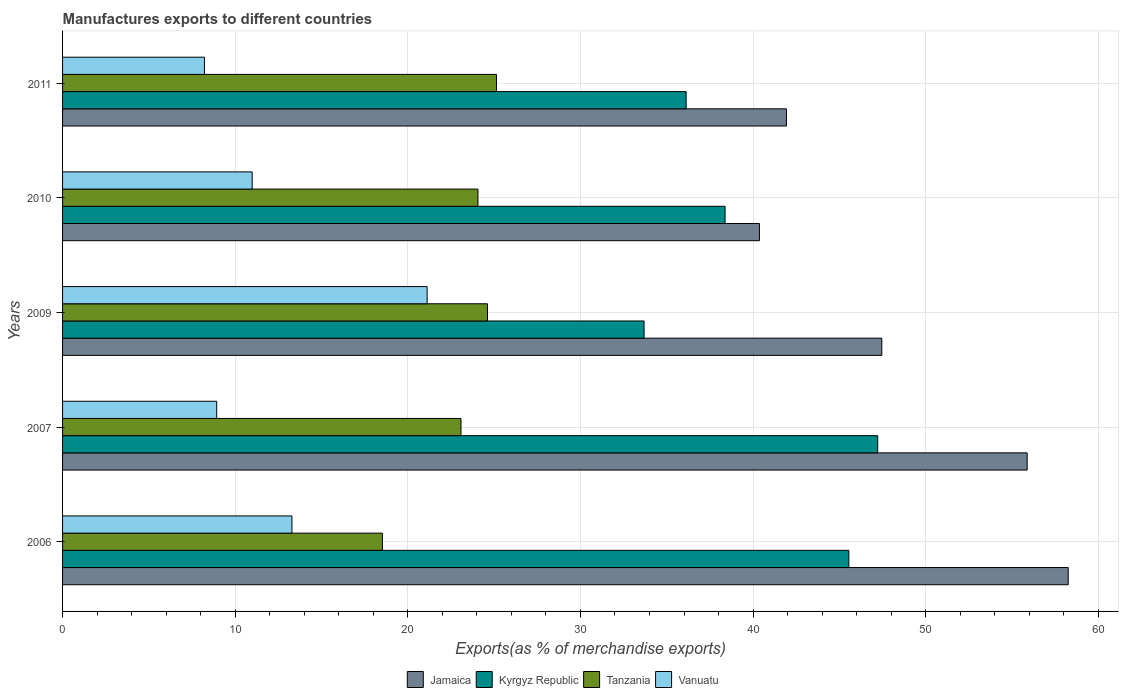How many different coloured bars are there?
Make the answer very short. 4. How many groups of bars are there?
Offer a very short reply. 5. What is the percentage of exports to different countries in Kyrgyz Republic in 2007?
Offer a very short reply. 47.22. Across all years, what is the maximum percentage of exports to different countries in Jamaica?
Make the answer very short. 58.26. Across all years, what is the minimum percentage of exports to different countries in Vanuatu?
Your answer should be compact. 8.22. What is the total percentage of exports to different countries in Kyrgyz Republic in the graph?
Your response must be concise. 200.95. What is the difference between the percentage of exports to different countries in Kyrgyz Republic in 2007 and that in 2009?
Keep it short and to the point. 13.53. What is the difference between the percentage of exports to different countries in Kyrgyz Republic in 2010 and the percentage of exports to different countries in Tanzania in 2007?
Keep it short and to the point. 15.3. What is the average percentage of exports to different countries in Tanzania per year?
Your response must be concise. 23.08. In the year 2007, what is the difference between the percentage of exports to different countries in Kyrgyz Republic and percentage of exports to different countries in Tanzania?
Make the answer very short. 24.14. What is the ratio of the percentage of exports to different countries in Kyrgyz Republic in 2010 to that in 2011?
Offer a very short reply. 1.06. Is the percentage of exports to different countries in Tanzania in 2006 less than that in 2010?
Ensure brevity in your answer.  Yes. Is the difference between the percentage of exports to different countries in Kyrgyz Republic in 2010 and 2011 greater than the difference between the percentage of exports to different countries in Tanzania in 2010 and 2011?
Provide a succinct answer. Yes. What is the difference between the highest and the second highest percentage of exports to different countries in Jamaica?
Offer a very short reply. 2.38. What is the difference between the highest and the lowest percentage of exports to different countries in Tanzania?
Make the answer very short. 6.61. Is it the case that in every year, the sum of the percentage of exports to different countries in Vanuatu and percentage of exports to different countries in Jamaica is greater than the sum of percentage of exports to different countries in Tanzania and percentage of exports to different countries in Kyrgyz Republic?
Ensure brevity in your answer.  Yes. What does the 1st bar from the top in 2006 represents?
Provide a succinct answer. Vanuatu. What does the 2nd bar from the bottom in 2010 represents?
Offer a terse response. Kyrgyz Republic. Is it the case that in every year, the sum of the percentage of exports to different countries in Tanzania and percentage of exports to different countries in Jamaica is greater than the percentage of exports to different countries in Kyrgyz Republic?
Give a very brief answer. Yes. How many years are there in the graph?
Offer a very short reply. 5. Does the graph contain any zero values?
Provide a succinct answer. No. What is the title of the graph?
Offer a very short reply. Manufactures exports to different countries. What is the label or title of the X-axis?
Offer a very short reply. Exports(as % of merchandise exports). What is the Exports(as % of merchandise exports) of Jamaica in 2006?
Offer a very short reply. 58.26. What is the Exports(as % of merchandise exports) of Kyrgyz Republic in 2006?
Offer a very short reply. 45.55. What is the Exports(as % of merchandise exports) in Tanzania in 2006?
Offer a terse response. 18.53. What is the Exports(as % of merchandise exports) of Vanuatu in 2006?
Keep it short and to the point. 13.29. What is the Exports(as % of merchandise exports) in Jamaica in 2007?
Provide a short and direct response. 55.88. What is the Exports(as % of merchandise exports) of Kyrgyz Republic in 2007?
Your response must be concise. 47.22. What is the Exports(as % of merchandise exports) of Tanzania in 2007?
Give a very brief answer. 23.08. What is the Exports(as % of merchandise exports) in Vanuatu in 2007?
Your response must be concise. 8.93. What is the Exports(as % of merchandise exports) in Jamaica in 2009?
Keep it short and to the point. 47.46. What is the Exports(as % of merchandise exports) of Kyrgyz Republic in 2009?
Offer a terse response. 33.69. What is the Exports(as % of merchandise exports) in Tanzania in 2009?
Offer a terse response. 24.61. What is the Exports(as % of merchandise exports) of Vanuatu in 2009?
Keep it short and to the point. 21.12. What is the Exports(as % of merchandise exports) in Jamaica in 2010?
Make the answer very short. 40.37. What is the Exports(as % of merchandise exports) in Kyrgyz Republic in 2010?
Provide a succinct answer. 38.38. What is the Exports(as % of merchandise exports) of Tanzania in 2010?
Provide a short and direct response. 24.06. What is the Exports(as % of merchandise exports) in Vanuatu in 2010?
Your response must be concise. 10.98. What is the Exports(as % of merchandise exports) of Jamaica in 2011?
Provide a short and direct response. 41.93. What is the Exports(as % of merchandise exports) in Kyrgyz Republic in 2011?
Give a very brief answer. 36.12. What is the Exports(as % of merchandise exports) in Tanzania in 2011?
Provide a short and direct response. 25.14. What is the Exports(as % of merchandise exports) of Vanuatu in 2011?
Your response must be concise. 8.22. Across all years, what is the maximum Exports(as % of merchandise exports) in Jamaica?
Your answer should be very brief. 58.26. Across all years, what is the maximum Exports(as % of merchandise exports) in Kyrgyz Republic?
Your answer should be compact. 47.22. Across all years, what is the maximum Exports(as % of merchandise exports) in Tanzania?
Provide a short and direct response. 25.14. Across all years, what is the maximum Exports(as % of merchandise exports) of Vanuatu?
Your answer should be compact. 21.12. Across all years, what is the minimum Exports(as % of merchandise exports) of Jamaica?
Offer a terse response. 40.37. Across all years, what is the minimum Exports(as % of merchandise exports) in Kyrgyz Republic?
Give a very brief answer. 33.69. Across all years, what is the minimum Exports(as % of merchandise exports) of Tanzania?
Provide a short and direct response. 18.53. Across all years, what is the minimum Exports(as % of merchandise exports) of Vanuatu?
Provide a short and direct response. 8.22. What is the total Exports(as % of merchandise exports) in Jamaica in the graph?
Offer a terse response. 243.89. What is the total Exports(as % of merchandise exports) in Kyrgyz Republic in the graph?
Keep it short and to the point. 200.95. What is the total Exports(as % of merchandise exports) in Tanzania in the graph?
Make the answer very short. 115.42. What is the total Exports(as % of merchandise exports) of Vanuatu in the graph?
Offer a very short reply. 62.54. What is the difference between the Exports(as % of merchandise exports) of Jamaica in 2006 and that in 2007?
Offer a very short reply. 2.38. What is the difference between the Exports(as % of merchandise exports) in Kyrgyz Republic in 2006 and that in 2007?
Your response must be concise. -1.67. What is the difference between the Exports(as % of merchandise exports) of Tanzania in 2006 and that in 2007?
Your answer should be compact. -4.55. What is the difference between the Exports(as % of merchandise exports) of Vanuatu in 2006 and that in 2007?
Make the answer very short. 4.36. What is the difference between the Exports(as % of merchandise exports) in Jamaica in 2006 and that in 2009?
Ensure brevity in your answer.  10.8. What is the difference between the Exports(as % of merchandise exports) of Kyrgyz Republic in 2006 and that in 2009?
Offer a very short reply. 11.86. What is the difference between the Exports(as % of merchandise exports) of Tanzania in 2006 and that in 2009?
Offer a very short reply. -6.09. What is the difference between the Exports(as % of merchandise exports) in Vanuatu in 2006 and that in 2009?
Your answer should be very brief. -7.83. What is the difference between the Exports(as % of merchandise exports) of Jamaica in 2006 and that in 2010?
Your response must be concise. 17.89. What is the difference between the Exports(as % of merchandise exports) of Kyrgyz Republic in 2006 and that in 2010?
Offer a terse response. 7.17. What is the difference between the Exports(as % of merchandise exports) of Tanzania in 2006 and that in 2010?
Offer a terse response. -5.54. What is the difference between the Exports(as % of merchandise exports) of Vanuatu in 2006 and that in 2010?
Give a very brief answer. 2.3. What is the difference between the Exports(as % of merchandise exports) of Jamaica in 2006 and that in 2011?
Give a very brief answer. 16.32. What is the difference between the Exports(as % of merchandise exports) of Kyrgyz Republic in 2006 and that in 2011?
Offer a very short reply. 9.43. What is the difference between the Exports(as % of merchandise exports) of Tanzania in 2006 and that in 2011?
Make the answer very short. -6.61. What is the difference between the Exports(as % of merchandise exports) in Vanuatu in 2006 and that in 2011?
Provide a short and direct response. 5.07. What is the difference between the Exports(as % of merchandise exports) in Jamaica in 2007 and that in 2009?
Offer a terse response. 8.42. What is the difference between the Exports(as % of merchandise exports) in Kyrgyz Republic in 2007 and that in 2009?
Offer a terse response. 13.53. What is the difference between the Exports(as % of merchandise exports) of Tanzania in 2007 and that in 2009?
Offer a very short reply. -1.53. What is the difference between the Exports(as % of merchandise exports) in Vanuatu in 2007 and that in 2009?
Offer a very short reply. -12.19. What is the difference between the Exports(as % of merchandise exports) in Jamaica in 2007 and that in 2010?
Give a very brief answer. 15.51. What is the difference between the Exports(as % of merchandise exports) of Kyrgyz Republic in 2007 and that in 2010?
Make the answer very short. 8.84. What is the difference between the Exports(as % of merchandise exports) in Tanzania in 2007 and that in 2010?
Provide a short and direct response. -0.98. What is the difference between the Exports(as % of merchandise exports) of Vanuatu in 2007 and that in 2010?
Make the answer very short. -2.05. What is the difference between the Exports(as % of merchandise exports) in Jamaica in 2007 and that in 2011?
Your response must be concise. 13.94. What is the difference between the Exports(as % of merchandise exports) in Kyrgyz Republic in 2007 and that in 2011?
Your answer should be very brief. 11.1. What is the difference between the Exports(as % of merchandise exports) in Tanzania in 2007 and that in 2011?
Keep it short and to the point. -2.06. What is the difference between the Exports(as % of merchandise exports) of Vanuatu in 2007 and that in 2011?
Your response must be concise. 0.71. What is the difference between the Exports(as % of merchandise exports) of Jamaica in 2009 and that in 2010?
Offer a terse response. 7.09. What is the difference between the Exports(as % of merchandise exports) in Kyrgyz Republic in 2009 and that in 2010?
Your answer should be very brief. -4.69. What is the difference between the Exports(as % of merchandise exports) of Tanzania in 2009 and that in 2010?
Ensure brevity in your answer.  0.55. What is the difference between the Exports(as % of merchandise exports) of Vanuatu in 2009 and that in 2010?
Your answer should be compact. 10.13. What is the difference between the Exports(as % of merchandise exports) in Jamaica in 2009 and that in 2011?
Give a very brief answer. 5.52. What is the difference between the Exports(as % of merchandise exports) in Kyrgyz Republic in 2009 and that in 2011?
Provide a short and direct response. -2.44. What is the difference between the Exports(as % of merchandise exports) of Tanzania in 2009 and that in 2011?
Ensure brevity in your answer.  -0.52. What is the difference between the Exports(as % of merchandise exports) in Vanuatu in 2009 and that in 2011?
Offer a very short reply. 12.9. What is the difference between the Exports(as % of merchandise exports) of Jamaica in 2010 and that in 2011?
Your answer should be very brief. -1.57. What is the difference between the Exports(as % of merchandise exports) of Kyrgyz Republic in 2010 and that in 2011?
Provide a short and direct response. 2.26. What is the difference between the Exports(as % of merchandise exports) in Tanzania in 2010 and that in 2011?
Keep it short and to the point. -1.07. What is the difference between the Exports(as % of merchandise exports) in Vanuatu in 2010 and that in 2011?
Ensure brevity in your answer.  2.77. What is the difference between the Exports(as % of merchandise exports) in Jamaica in 2006 and the Exports(as % of merchandise exports) in Kyrgyz Republic in 2007?
Your answer should be compact. 11.04. What is the difference between the Exports(as % of merchandise exports) in Jamaica in 2006 and the Exports(as % of merchandise exports) in Tanzania in 2007?
Your answer should be compact. 35.18. What is the difference between the Exports(as % of merchandise exports) of Jamaica in 2006 and the Exports(as % of merchandise exports) of Vanuatu in 2007?
Your answer should be compact. 49.33. What is the difference between the Exports(as % of merchandise exports) in Kyrgyz Republic in 2006 and the Exports(as % of merchandise exports) in Tanzania in 2007?
Make the answer very short. 22.47. What is the difference between the Exports(as % of merchandise exports) of Kyrgyz Republic in 2006 and the Exports(as % of merchandise exports) of Vanuatu in 2007?
Give a very brief answer. 36.62. What is the difference between the Exports(as % of merchandise exports) of Tanzania in 2006 and the Exports(as % of merchandise exports) of Vanuatu in 2007?
Offer a very short reply. 9.6. What is the difference between the Exports(as % of merchandise exports) in Jamaica in 2006 and the Exports(as % of merchandise exports) in Kyrgyz Republic in 2009?
Provide a short and direct response. 24.57. What is the difference between the Exports(as % of merchandise exports) of Jamaica in 2006 and the Exports(as % of merchandise exports) of Tanzania in 2009?
Your answer should be compact. 33.64. What is the difference between the Exports(as % of merchandise exports) of Jamaica in 2006 and the Exports(as % of merchandise exports) of Vanuatu in 2009?
Give a very brief answer. 37.14. What is the difference between the Exports(as % of merchandise exports) in Kyrgyz Republic in 2006 and the Exports(as % of merchandise exports) in Tanzania in 2009?
Your answer should be compact. 20.93. What is the difference between the Exports(as % of merchandise exports) in Kyrgyz Republic in 2006 and the Exports(as % of merchandise exports) in Vanuatu in 2009?
Your answer should be compact. 24.43. What is the difference between the Exports(as % of merchandise exports) of Tanzania in 2006 and the Exports(as % of merchandise exports) of Vanuatu in 2009?
Provide a succinct answer. -2.59. What is the difference between the Exports(as % of merchandise exports) in Jamaica in 2006 and the Exports(as % of merchandise exports) in Kyrgyz Republic in 2010?
Provide a succinct answer. 19.88. What is the difference between the Exports(as % of merchandise exports) in Jamaica in 2006 and the Exports(as % of merchandise exports) in Tanzania in 2010?
Your answer should be very brief. 34.19. What is the difference between the Exports(as % of merchandise exports) of Jamaica in 2006 and the Exports(as % of merchandise exports) of Vanuatu in 2010?
Keep it short and to the point. 47.27. What is the difference between the Exports(as % of merchandise exports) in Kyrgyz Republic in 2006 and the Exports(as % of merchandise exports) in Tanzania in 2010?
Make the answer very short. 21.48. What is the difference between the Exports(as % of merchandise exports) in Kyrgyz Republic in 2006 and the Exports(as % of merchandise exports) in Vanuatu in 2010?
Your response must be concise. 34.56. What is the difference between the Exports(as % of merchandise exports) of Tanzania in 2006 and the Exports(as % of merchandise exports) of Vanuatu in 2010?
Offer a very short reply. 7.54. What is the difference between the Exports(as % of merchandise exports) of Jamaica in 2006 and the Exports(as % of merchandise exports) of Kyrgyz Republic in 2011?
Your answer should be very brief. 22.13. What is the difference between the Exports(as % of merchandise exports) of Jamaica in 2006 and the Exports(as % of merchandise exports) of Tanzania in 2011?
Ensure brevity in your answer.  33.12. What is the difference between the Exports(as % of merchandise exports) of Jamaica in 2006 and the Exports(as % of merchandise exports) of Vanuatu in 2011?
Provide a succinct answer. 50.04. What is the difference between the Exports(as % of merchandise exports) in Kyrgyz Republic in 2006 and the Exports(as % of merchandise exports) in Tanzania in 2011?
Your response must be concise. 20.41. What is the difference between the Exports(as % of merchandise exports) in Kyrgyz Republic in 2006 and the Exports(as % of merchandise exports) in Vanuatu in 2011?
Your response must be concise. 37.33. What is the difference between the Exports(as % of merchandise exports) in Tanzania in 2006 and the Exports(as % of merchandise exports) in Vanuatu in 2011?
Your response must be concise. 10.31. What is the difference between the Exports(as % of merchandise exports) of Jamaica in 2007 and the Exports(as % of merchandise exports) of Kyrgyz Republic in 2009?
Offer a terse response. 22.19. What is the difference between the Exports(as % of merchandise exports) in Jamaica in 2007 and the Exports(as % of merchandise exports) in Tanzania in 2009?
Make the answer very short. 31.26. What is the difference between the Exports(as % of merchandise exports) in Jamaica in 2007 and the Exports(as % of merchandise exports) in Vanuatu in 2009?
Provide a short and direct response. 34.76. What is the difference between the Exports(as % of merchandise exports) in Kyrgyz Republic in 2007 and the Exports(as % of merchandise exports) in Tanzania in 2009?
Give a very brief answer. 22.6. What is the difference between the Exports(as % of merchandise exports) of Kyrgyz Republic in 2007 and the Exports(as % of merchandise exports) of Vanuatu in 2009?
Offer a terse response. 26.1. What is the difference between the Exports(as % of merchandise exports) of Tanzania in 2007 and the Exports(as % of merchandise exports) of Vanuatu in 2009?
Your response must be concise. 1.96. What is the difference between the Exports(as % of merchandise exports) in Jamaica in 2007 and the Exports(as % of merchandise exports) in Kyrgyz Republic in 2010?
Offer a very short reply. 17.5. What is the difference between the Exports(as % of merchandise exports) in Jamaica in 2007 and the Exports(as % of merchandise exports) in Tanzania in 2010?
Provide a short and direct response. 31.82. What is the difference between the Exports(as % of merchandise exports) of Jamaica in 2007 and the Exports(as % of merchandise exports) of Vanuatu in 2010?
Make the answer very short. 44.89. What is the difference between the Exports(as % of merchandise exports) of Kyrgyz Republic in 2007 and the Exports(as % of merchandise exports) of Tanzania in 2010?
Offer a terse response. 23.16. What is the difference between the Exports(as % of merchandise exports) in Kyrgyz Republic in 2007 and the Exports(as % of merchandise exports) in Vanuatu in 2010?
Make the answer very short. 36.24. What is the difference between the Exports(as % of merchandise exports) in Tanzania in 2007 and the Exports(as % of merchandise exports) in Vanuatu in 2010?
Give a very brief answer. 12.1. What is the difference between the Exports(as % of merchandise exports) in Jamaica in 2007 and the Exports(as % of merchandise exports) in Kyrgyz Republic in 2011?
Your answer should be compact. 19.76. What is the difference between the Exports(as % of merchandise exports) of Jamaica in 2007 and the Exports(as % of merchandise exports) of Tanzania in 2011?
Provide a short and direct response. 30.74. What is the difference between the Exports(as % of merchandise exports) in Jamaica in 2007 and the Exports(as % of merchandise exports) in Vanuatu in 2011?
Give a very brief answer. 47.66. What is the difference between the Exports(as % of merchandise exports) of Kyrgyz Republic in 2007 and the Exports(as % of merchandise exports) of Tanzania in 2011?
Your answer should be compact. 22.08. What is the difference between the Exports(as % of merchandise exports) in Kyrgyz Republic in 2007 and the Exports(as % of merchandise exports) in Vanuatu in 2011?
Ensure brevity in your answer.  39. What is the difference between the Exports(as % of merchandise exports) in Tanzania in 2007 and the Exports(as % of merchandise exports) in Vanuatu in 2011?
Offer a terse response. 14.86. What is the difference between the Exports(as % of merchandise exports) in Jamaica in 2009 and the Exports(as % of merchandise exports) in Kyrgyz Republic in 2010?
Offer a very short reply. 9.08. What is the difference between the Exports(as % of merchandise exports) of Jamaica in 2009 and the Exports(as % of merchandise exports) of Tanzania in 2010?
Make the answer very short. 23.39. What is the difference between the Exports(as % of merchandise exports) in Jamaica in 2009 and the Exports(as % of merchandise exports) in Vanuatu in 2010?
Your answer should be very brief. 36.47. What is the difference between the Exports(as % of merchandise exports) of Kyrgyz Republic in 2009 and the Exports(as % of merchandise exports) of Tanzania in 2010?
Provide a short and direct response. 9.62. What is the difference between the Exports(as % of merchandise exports) of Kyrgyz Republic in 2009 and the Exports(as % of merchandise exports) of Vanuatu in 2010?
Offer a very short reply. 22.7. What is the difference between the Exports(as % of merchandise exports) of Tanzania in 2009 and the Exports(as % of merchandise exports) of Vanuatu in 2010?
Your answer should be compact. 13.63. What is the difference between the Exports(as % of merchandise exports) in Jamaica in 2009 and the Exports(as % of merchandise exports) in Kyrgyz Republic in 2011?
Provide a short and direct response. 11.34. What is the difference between the Exports(as % of merchandise exports) of Jamaica in 2009 and the Exports(as % of merchandise exports) of Tanzania in 2011?
Offer a very short reply. 22.32. What is the difference between the Exports(as % of merchandise exports) of Jamaica in 2009 and the Exports(as % of merchandise exports) of Vanuatu in 2011?
Offer a very short reply. 39.24. What is the difference between the Exports(as % of merchandise exports) in Kyrgyz Republic in 2009 and the Exports(as % of merchandise exports) in Tanzania in 2011?
Ensure brevity in your answer.  8.55. What is the difference between the Exports(as % of merchandise exports) of Kyrgyz Republic in 2009 and the Exports(as % of merchandise exports) of Vanuatu in 2011?
Offer a very short reply. 25.47. What is the difference between the Exports(as % of merchandise exports) in Tanzania in 2009 and the Exports(as % of merchandise exports) in Vanuatu in 2011?
Your answer should be very brief. 16.4. What is the difference between the Exports(as % of merchandise exports) of Jamaica in 2010 and the Exports(as % of merchandise exports) of Kyrgyz Republic in 2011?
Offer a very short reply. 4.25. What is the difference between the Exports(as % of merchandise exports) of Jamaica in 2010 and the Exports(as % of merchandise exports) of Tanzania in 2011?
Ensure brevity in your answer.  15.23. What is the difference between the Exports(as % of merchandise exports) of Jamaica in 2010 and the Exports(as % of merchandise exports) of Vanuatu in 2011?
Your response must be concise. 32.15. What is the difference between the Exports(as % of merchandise exports) in Kyrgyz Republic in 2010 and the Exports(as % of merchandise exports) in Tanzania in 2011?
Make the answer very short. 13.24. What is the difference between the Exports(as % of merchandise exports) of Kyrgyz Republic in 2010 and the Exports(as % of merchandise exports) of Vanuatu in 2011?
Provide a short and direct response. 30.16. What is the difference between the Exports(as % of merchandise exports) of Tanzania in 2010 and the Exports(as % of merchandise exports) of Vanuatu in 2011?
Offer a very short reply. 15.84. What is the average Exports(as % of merchandise exports) of Jamaica per year?
Provide a short and direct response. 48.78. What is the average Exports(as % of merchandise exports) of Kyrgyz Republic per year?
Make the answer very short. 40.19. What is the average Exports(as % of merchandise exports) of Tanzania per year?
Ensure brevity in your answer.  23.08. What is the average Exports(as % of merchandise exports) of Vanuatu per year?
Give a very brief answer. 12.51. In the year 2006, what is the difference between the Exports(as % of merchandise exports) of Jamaica and Exports(as % of merchandise exports) of Kyrgyz Republic?
Ensure brevity in your answer.  12.71. In the year 2006, what is the difference between the Exports(as % of merchandise exports) of Jamaica and Exports(as % of merchandise exports) of Tanzania?
Your answer should be very brief. 39.73. In the year 2006, what is the difference between the Exports(as % of merchandise exports) of Jamaica and Exports(as % of merchandise exports) of Vanuatu?
Make the answer very short. 44.97. In the year 2006, what is the difference between the Exports(as % of merchandise exports) of Kyrgyz Republic and Exports(as % of merchandise exports) of Tanzania?
Keep it short and to the point. 27.02. In the year 2006, what is the difference between the Exports(as % of merchandise exports) of Kyrgyz Republic and Exports(as % of merchandise exports) of Vanuatu?
Your answer should be compact. 32.26. In the year 2006, what is the difference between the Exports(as % of merchandise exports) of Tanzania and Exports(as % of merchandise exports) of Vanuatu?
Provide a short and direct response. 5.24. In the year 2007, what is the difference between the Exports(as % of merchandise exports) of Jamaica and Exports(as % of merchandise exports) of Kyrgyz Republic?
Your response must be concise. 8.66. In the year 2007, what is the difference between the Exports(as % of merchandise exports) in Jamaica and Exports(as % of merchandise exports) in Tanzania?
Offer a very short reply. 32.8. In the year 2007, what is the difference between the Exports(as % of merchandise exports) of Jamaica and Exports(as % of merchandise exports) of Vanuatu?
Offer a very short reply. 46.95. In the year 2007, what is the difference between the Exports(as % of merchandise exports) in Kyrgyz Republic and Exports(as % of merchandise exports) in Tanzania?
Your answer should be compact. 24.14. In the year 2007, what is the difference between the Exports(as % of merchandise exports) of Kyrgyz Republic and Exports(as % of merchandise exports) of Vanuatu?
Give a very brief answer. 38.29. In the year 2007, what is the difference between the Exports(as % of merchandise exports) of Tanzania and Exports(as % of merchandise exports) of Vanuatu?
Your response must be concise. 14.15. In the year 2009, what is the difference between the Exports(as % of merchandise exports) of Jamaica and Exports(as % of merchandise exports) of Kyrgyz Republic?
Your response must be concise. 13.77. In the year 2009, what is the difference between the Exports(as % of merchandise exports) in Jamaica and Exports(as % of merchandise exports) in Tanzania?
Provide a short and direct response. 22.84. In the year 2009, what is the difference between the Exports(as % of merchandise exports) in Jamaica and Exports(as % of merchandise exports) in Vanuatu?
Give a very brief answer. 26.34. In the year 2009, what is the difference between the Exports(as % of merchandise exports) in Kyrgyz Republic and Exports(as % of merchandise exports) in Tanzania?
Give a very brief answer. 9.07. In the year 2009, what is the difference between the Exports(as % of merchandise exports) of Kyrgyz Republic and Exports(as % of merchandise exports) of Vanuatu?
Make the answer very short. 12.57. In the year 2009, what is the difference between the Exports(as % of merchandise exports) in Tanzania and Exports(as % of merchandise exports) in Vanuatu?
Keep it short and to the point. 3.5. In the year 2010, what is the difference between the Exports(as % of merchandise exports) in Jamaica and Exports(as % of merchandise exports) in Kyrgyz Republic?
Ensure brevity in your answer.  1.99. In the year 2010, what is the difference between the Exports(as % of merchandise exports) in Jamaica and Exports(as % of merchandise exports) in Tanzania?
Ensure brevity in your answer.  16.3. In the year 2010, what is the difference between the Exports(as % of merchandise exports) of Jamaica and Exports(as % of merchandise exports) of Vanuatu?
Make the answer very short. 29.38. In the year 2010, what is the difference between the Exports(as % of merchandise exports) of Kyrgyz Republic and Exports(as % of merchandise exports) of Tanzania?
Ensure brevity in your answer.  14.32. In the year 2010, what is the difference between the Exports(as % of merchandise exports) of Kyrgyz Republic and Exports(as % of merchandise exports) of Vanuatu?
Give a very brief answer. 27.39. In the year 2010, what is the difference between the Exports(as % of merchandise exports) in Tanzania and Exports(as % of merchandise exports) in Vanuatu?
Offer a terse response. 13.08. In the year 2011, what is the difference between the Exports(as % of merchandise exports) in Jamaica and Exports(as % of merchandise exports) in Kyrgyz Republic?
Your answer should be very brief. 5.81. In the year 2011, what is the difference between the Exports(as % of merchandise exports) in Jamaica and Exports(as % of merchandise exports) in Tanzania?
Offer a terse response. 16.8. In the year 2011, what is the difference between the Exports(as % of merchandise exports) of Jamaica and Exports(as % of merchandise exports) of Vanuatu?
Offer a very short reply. 33.72. In the year 2011, what is the difference between the Exports(as % of merchandise exports) in Kyrgyz Republic and Exports(as % of merchandise exports) in Tanzania?
Offer a terse response. 10.98. In the year 2011, what is the difference between the Exports(as % of merchandise exports) in Kyrgyz Republic and Exports(as % of merchandise exports) in Vanuatu?
Your answer should be compact. 27.9. In the year 2011, what is the difference between the Exports(as % of merchandise exports) in Tanzania and Exports(as % of merchandise exports) in Vanuatu?
Make the answer very short. 16.92. What is the ratio of the Exports(as % of merchandise exports) of Jamaica in 2006 to that in 2007?
Provide a succinct answer. 1.04. What is the ratio of the Exports(as % of merchandise exports) of Kyrgyz Republic in 2006 to that in 2007?
Offer a terse response. 0.96. What is the ratio of the Exports(as % of merchandise exports) in Tanzania in 2006 to that in 2007?
Provide a succinct answer. 0.8. What is the ratio of the Exports(as % of merchandise exports) of Vanuatu in 2006 to that in 2007?
Make the answer very short. 1.49. What is the ratio of the Exports(as % of merchandise exports) in Jamaica in 2006 to that in 2009?
Provide a succinct answer. 1.23. What is the ratio of the Exports(as % of merchandise exports) of Kyrgyz Republic in 2006 to that in 2009?
Provide a succinct answer. 1.35. What is the ratio of the Exports(as % of merchandise exports) of Tanzania in 2006 to that in 2009?
Your response must be concise. 0.75. What is the ratio of the Exports(as % of merchandise exports) in Vanuatu in 2006 to that in 2009?
Your answer should be very brief. 0.63. What is the ratio of the Exports(as % of merchandise exports) of Jamaica in 2006 to that in 2010?
Provide a short and direct response. 1.44. What is the ratio of the Exports(as % of merchandise exports) in Kyrgyz Republic in 2006 to that in 2010?
Offer a terse response. 1.19. What is the ratio of the Exports(as % of merchandise exports) in Tanzania in 2006 to that in 2010?
Keep it short and to the point. 0.77. What is the ratio of the Exports(as % of merchandise exports) in Vanuatu in 2006 to that in 2010?
Keep it short and to the point. 1.21. What is the ratio of the Exports(as % of merchandise exports) of Jamaica in 2006 to that in 2011?
Your answer should be very brief. 1.39. What is the ratio of the Exports(as % of merchandise exports) in Kyrgyz Republic in 2006 to that in 2011?
Your answer should be very brief. 1.26. What is the ratio of the Exports(as % of merchandise exports) in Tanzania in 2006 to that in 2011?
Make the answer very short. 0.74. What is the ratio of the Exports(as % of merchandise exports) in Vanuatu in 2006 to that in 2011?
Provide a succinct answer. 1.62. What is the ratio of the Exports(as % of merchandise exports) in Jamaica in 2007 to that in 2009?
Ensure brevity in your answer.  1.18. What is the ratio of the Exports(as % of merchandise exports) of Kyrgyz Republic in 2007 to that in 2009?
Your answer should be very brief. 1.4. What is the ratio of the Exports(as % of merchandise exports) in Tanzania in 2007 to that in 2009?
Your answer should be very brief. 0.94. What is the ratio of the Exports(as % of merchandise exports) of Vanuatu in 2007 to that in 2009?
Provide a short and direct response. 0.42. What is the ratio of the Exports(as % of merchandise exports) in Jamaica in 2007 to that in 2010?
Provide a succinct answer. 1.38. What is the ratio of the Exports(as % of merchandise exports) in Kyrgyz Republic in 2007 to that in 2010?
Your answer should be compact. 1.23. What is the ratio of the Exports(as % of merchandise exports) of Tanzania in 2007 to that in 2010?
Your answer should be very brief. 0.96. What is the ratio of the Exports(as % of merchandise exports) of Vanuatu in 2007 to that in 2010?
Offer a very short reply. 0.81. What is the ratio of the Exports(as % of merchandise exports) of Jamaica in 2007 to that in 2011?
Offer a terse response. 1.33. What is the ratio of the Exports(as % of merchandise exports) in Kyrgyz Republic in 2007 to that in 2011?
Keep it short and to the point. 1.31. What is the ratio of the Exports(as % of merchandise exports) of Tanzania in 2007 to that in 2011?
Your response must be concise. 0.92. What is the ratio of the Exports(as % of merchandise exports) of Vanuatu in 2007 to that in 2011?
Give a very brief answer. 1.09. What is the ratio of the Exports(as % of merchandise exports) of Jamaica in 2009 to that in 2010?
Provide a succinct answer. 1.18. What is the ratio of the Exports(as % of merchandise exports) of Kyrgyz Republic in 2009 to that in 2010?
Provide a succinct answer. 0.88. What is the ratio of the Exports(as % of merchandise exports) in Tanzania in 2009 to that in 2010?
Keep it short and to the point. 1.02. What is the ratio of the Exports(as % of merchandise exports) of Vanuatu in 2009 to that in 2010?
Keep it short and to the point. 1.92. What is the ratio of the Exports(as % of merchandise exports) of Jamaica in 2009 to that in 2011?
Your answer should be very brief. 1.13. What is the ratio of the Exports(as % of merchandise exports) in Kyrgyz Republic in 2009 to that in 2011?
Your answer should be compact. 0.93. What is the ratio of the Exports(as % of merchandise exports) in Tanzania in 2009 to that in 2011?
Make the answer very short. 0.98. What is the ratio of the Exports(as % of merchandise exports) in Vanuatu in 2009 to that in 2011?
Offer a very short reply. 2.57. What is the ratio of the Exports(as % of merchandise exports) of Jamaica in 2010 to that in 2011?
Provide a succinct answer. 0.96. What is the ratio of the Exports(as % of merchandise exports) of Tanzania in 2010 to that in 2011?
Your answer should be compact. 0.96. What is the ratio of the Exports(as % of merchandise exports) in Vanuatu in 2010 to that in 2011?
Your answer should be compact. 1.34. What is the difference between the highest and the second highest Exports(as % of merchandise exports) of Jamaica?
Offer a very short reply. 2.38. What is the difference between the highest and the second highest Exports(as % of merchandise exports) of Kyrgyz Republic?
Offer a terse response. 1.67. What is the difference between the highest and the second highest Exports(as % of merchandise exports) in Tanzania?
Your response must be concise. 0.52. What is the difference between the highest and the second highest Exports(as % of merchandise exports) of Vanuatu?
Provide a short and direct response. 7.83. What is the difference between the highest and the lowest Exports(as % of merchandise exports) of Jamaica?
Offer a very short reply. 17.89. What is the difference between the highest and the lowest Exports(as % of merchandise exports) in Kyrgyz Republic?
Provide a succinct answer. 13.53. What is the difference between the highest and the lowest Exports(as % of merchandise exports) in Tanzania?
Keep it short and to the point. 6.61. What is the difference between the highest and the lowest Exports(as % of merchandise exports) in Vanuatu?
Your response must be concise. 12.9. 